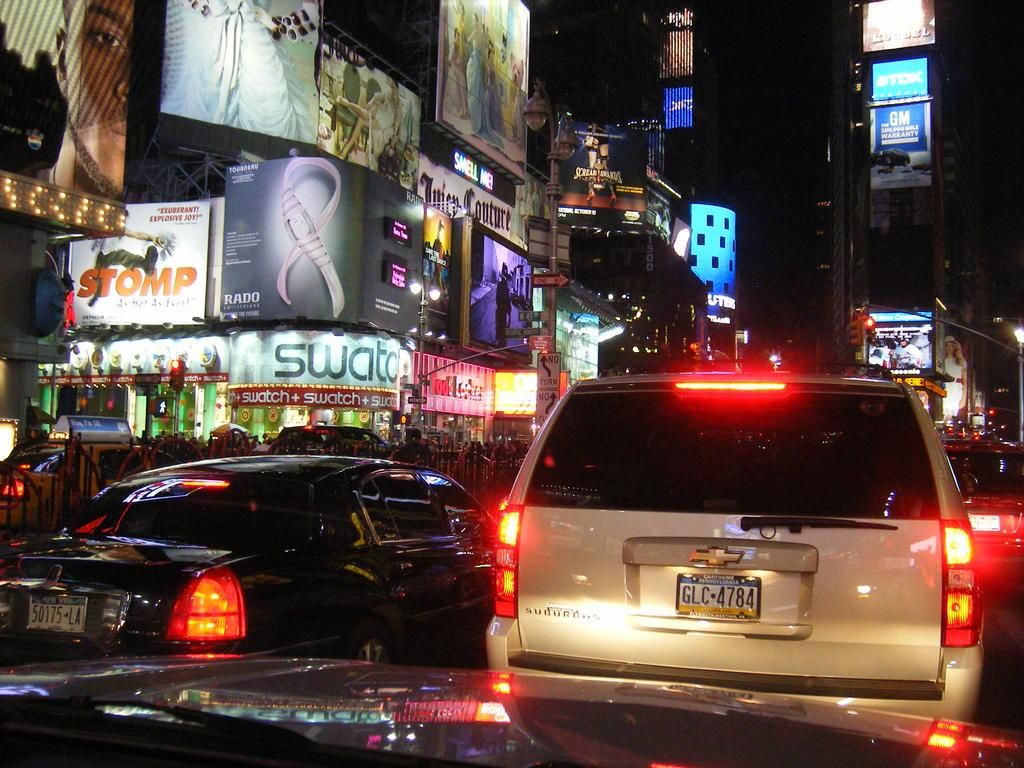<image>
Render a clear and concise summary of the photo. Storefronts like SWATCH and ads for Stomp and GM light up the crowded NYC night. 